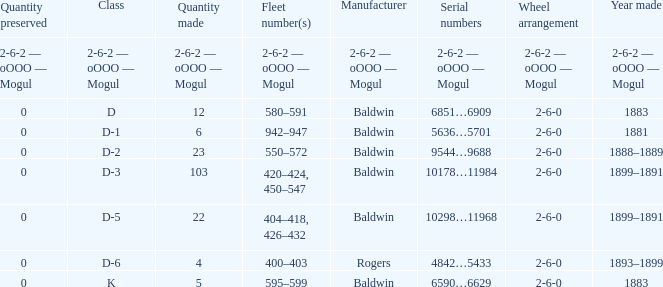What is the class when the quantity perserved is 0 and the quantity made is 5? K. 